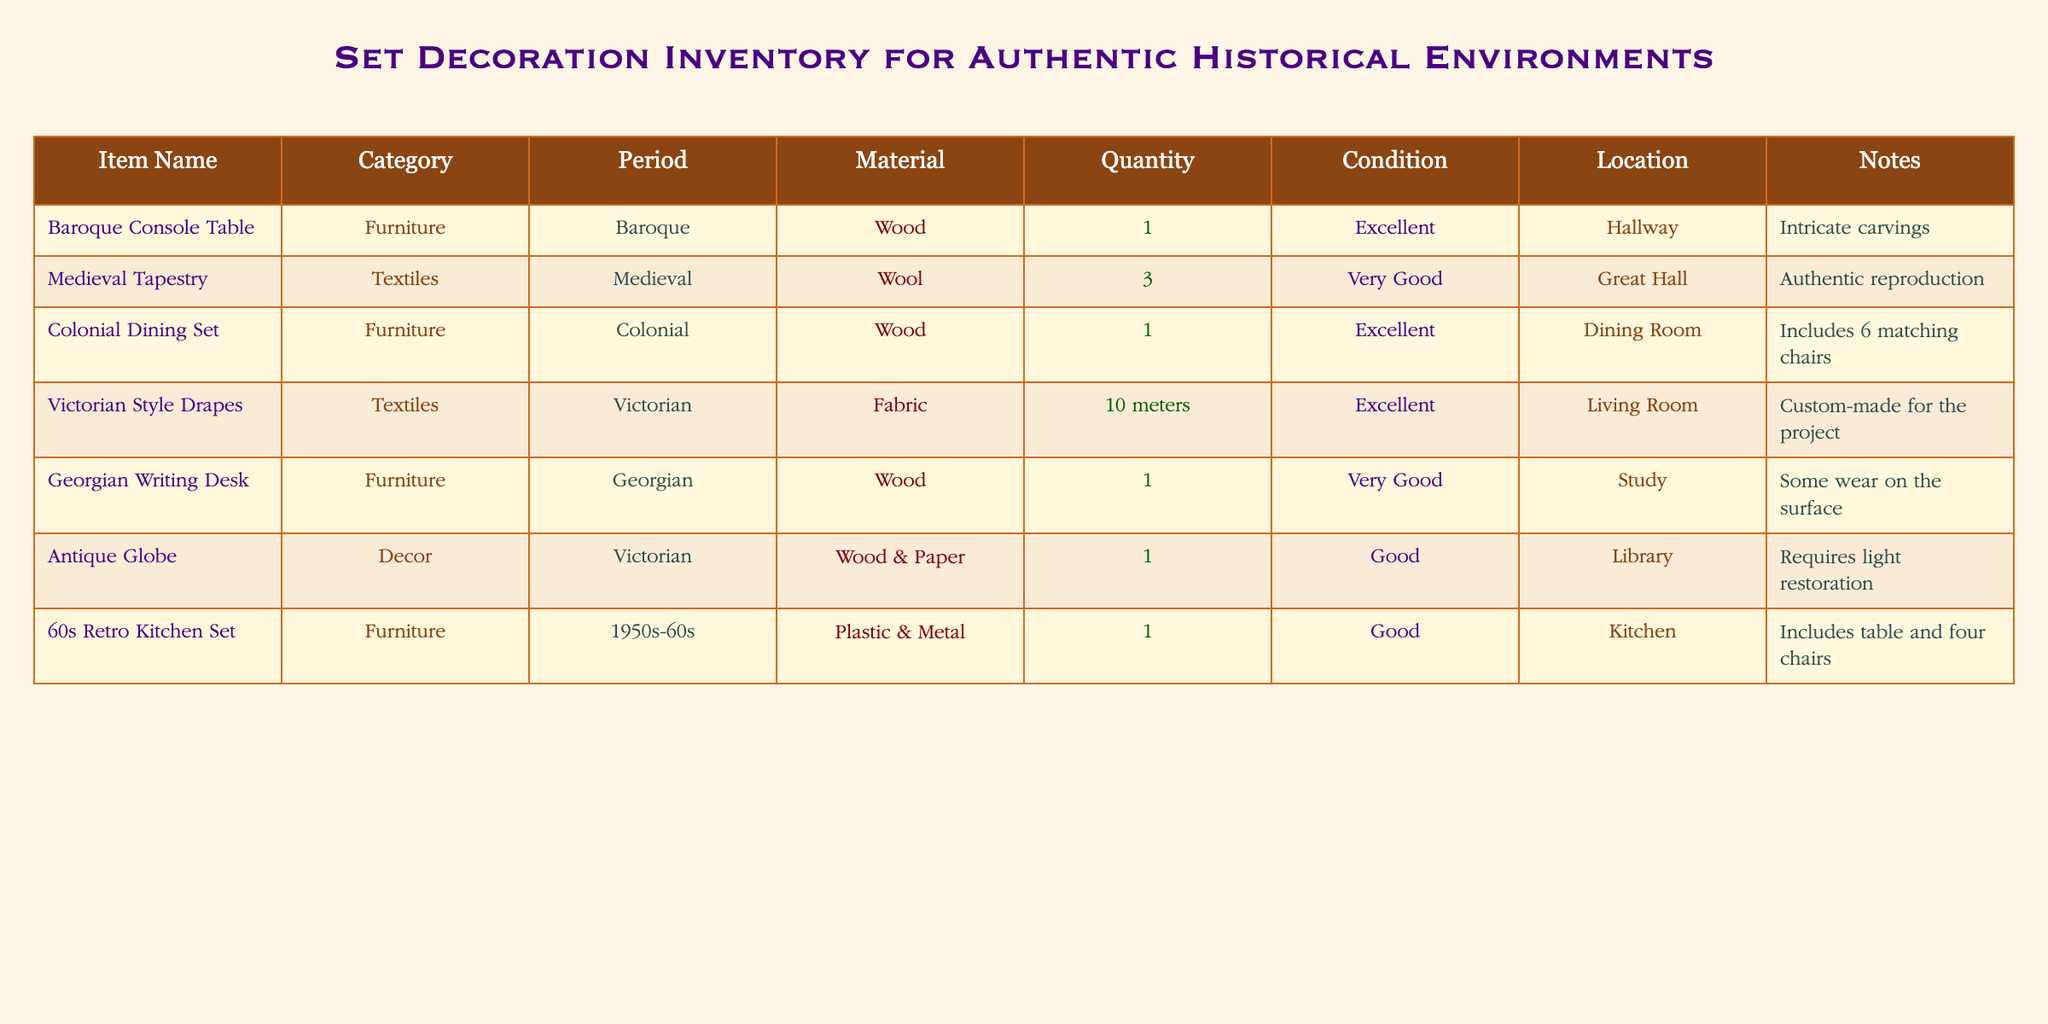What is the material used for the Baroque Console Table? The table specifies that the material used for the Baroque Console Table is wood.
Answer: Wood How many items in total are classified as Textiles? There are three items categorized as Textiles: Medieval Tapestry, Victorian Style Drapes, and the total quantity of these items is 3 (1 Medieval Tapestry) + 10 meters (Victorian Style Drapes).
Answer: 2 Is the Colonial Dining Set in excellent condition? The table states that the Colonial Dining Set is marked as 'Excellent' in condition.
Answer: Yes What item has the largest quantity in the inventory? The largest quantity is held by the Victorian Style Drapes, which are measured as 10 meters in quantity.
Answer: Victorian Style Drapes How many furniture items are located in the Living Room? The only furniture item listed in the Living Room is the Victorian Style Drapes, so the count of furniture items there is 0 (since drapes are textiles).
Answer: 0 What is the average condition rating of the furniture items? The condition ratings for furniture items are Excellent (2 items), Very Good (2 items), and Good (1 item). To average these, we can assign Excellent = 2, Very Good = 1.5, and Good = 1. The average would be (2+2+1.5+1)/5 = 1.5, which falls between Very Good and Excellent.
Answer: Very Good Is the Antique Globe located in the Library? The table indicates that the Antique Globe is placed in the Library, affirming this fact with the information directly present.
Answer: Yes How many materials are used for the 1950s-60s kitchen set? The kitchen set is made from both Plastic and Metal, which indicates that there are 2 materials used for this item.
Answer: 2 